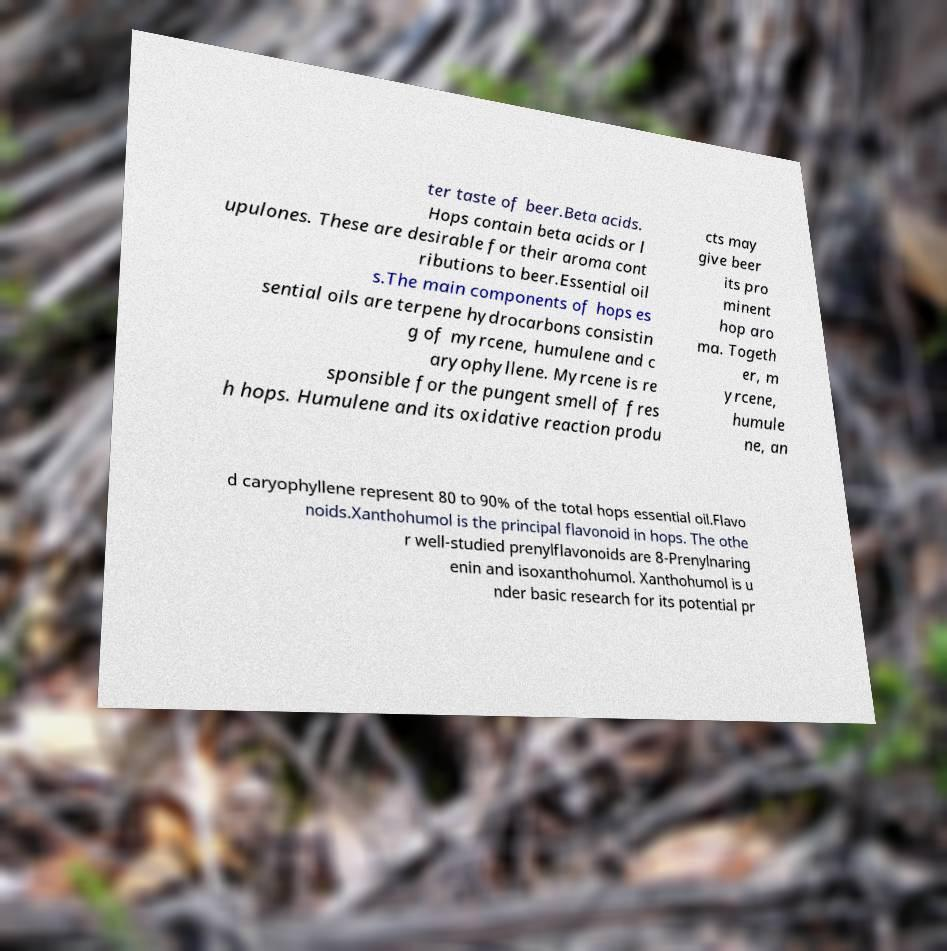Can you read and provide the text displayed in the image?This photo seems to have some interesting text. Can you extract and type it out for me? ter taste of beer.Beta acids. Hops contain beta acids or l upulones. These are desirable for their aroma cont ributions to beer.Essential oil s.The main components of hops es sential oils are terpene hydrocarbons consistin g of myrcene, humulene and c aryophyllene. Myrcene is re sponsible for the pungent smell of fres h hops. Humulene and its oxidative reaction produ cts may give beer its pro minent hop aro ma. Togeth er, m yrcene, humule ne, an d caryophyllene represent 80 to 90% of the total hops essential oil.Flavo noids.Xanthohumol is the principal flavonoid in hops. The othe r well-studied prenylflavonoids are 8-Prenylnaring enin and isoxanthohumol. Xanthohumol is u nder basic research for its potential pr 